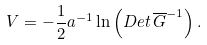Convert formula to latex. <formula><loc_0><loc_0><loc_500><loc_500>V = - \frac { 1 } { 2 } a ^ { - 1 } \ln \left ( D e t \, \overline { G } ^ { - 1 } \right ) .</formula> 